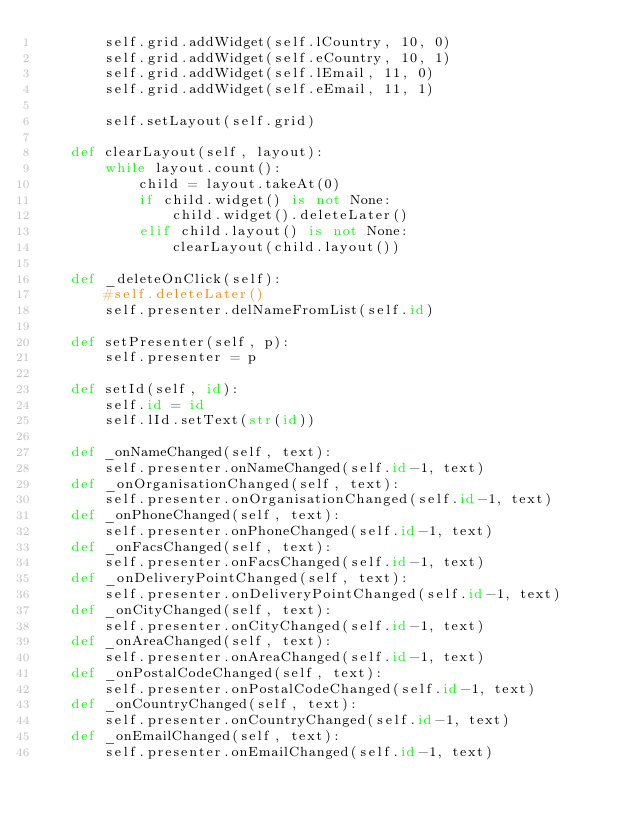<code> <loc_0><loc_0><loc_500><loc_500><_Python_>		self.grid.addWidget(self.lCountry, 10, 0)
		self.grid.addWidget(self.eCountry, 10, 1)
		self.grid.addWidget(self.lEmail, 11, 0)
		self.grid.addWidget(self.eEmail, 11, 1)

		self.setLayout(self.grid)

	def clearLayout(self, layout):
		while layout.count():
			child = layout.takeAt(0)
			if child.widget() is not None:
				child.widget().deleteLater()
			elif child.layout() is not None:
				clearLayout(child.layout())

	def _deleteOnClick(self):
		#self.deleteLater()
		self.presenter.delNameFromList(self.id)

	def setPresenter(self, p):
		self.presenter = p
	
	def setId(self, id):
		self.id = id
		self.lId.setText(str(id))
	
	def _onNameChanged(self, text):
		self.presenter.onNameChanged(self.id-1, text)
	def _onOrganisationChanged(self, text):
		self.presenter.onOrganisationChanged(self.id-1, text)
	def _onPhoneChanged(self, text):
		self.presenter.onPhoneChanged(self.id-1, text)
	def _onFacsChanged(self, text):
		self.presenter.onFacsChanged(self.id-1, text)
	def _onDeliveryPointChanged(self, text):
		self.presenter.onDeliveryPointChanged(self.id-1, text)
	def _onCityChanged(self, text):
		self.presenter.onCityChanged(self.id-1, text)
	def _onAreaChanged(self, text):
		self.presenter.onAreaChanged(self.id-1, text)
	def _onPostalCodeChanged(self, text):
		self.presenter.onPostalCodeChanged(self.id-1, text)
	def _onCountryChanged(self, text):
		self.presenter.onCountryChanged(self.id-1, text)
	def _onEmailChanged(self, text):
		self.presenter.onEmailChanged(self.id-1, text)
</code> 